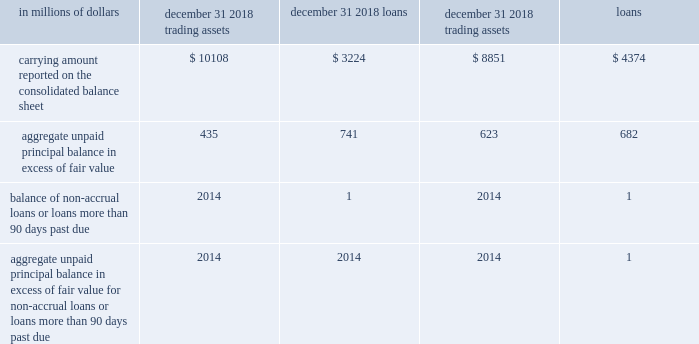Own debt valuation adjustments ( dva ) own debt valuation adjustments are recognized on citi 2019s liabilities for which the fair value option has been elected using citi 2019s credit spreads observed in the bond market .
Effective january 1 , 2016 , changes in fair value of fair value option liabilities related to changes in citigroup 2019s own credit spreads ( dva ) are reflected as a component of aoci .
See note 1 to the consolidated financial statements for additional information .
Among other variables , the fair value of liabilities for which the fair value option has been elected ( other than non-recourse and similar liabilities ) is impacted by the narrowing or widening of the company 2019s credit spreads .
The estimated changes in the fair value of these liabilities due to such changes in the company 2019s own credit spread ( or instrument-specific credit risk ) were a gain of $ 1415 million and a loss of $ 680 million for the years ended december 31 , 2018 and 2017 , respectively .
Changes in fair value resulting from changes in instrument-specific credit risk were estimated by incorporating the company 2019s current credit spreads observable in the bond market into the relevant valuation technique used to value each liability as described above .
The fair value option for financial assets and financial liabilities selected portfolios of securities purchased under agreements to resell , securities borrowed , securities sold under agreements to repurchase , securities loaned and certain non-collateralized short-term borrowings the company elected the fair value option for certain portfolios of fixed income securities purchased under agreements to resell and fixed income securities sold under agreements to repurchase , securities borrowed , securities loaned and certain non-collateralized short-term borrowings held primarily by broker-dealer entities in the united states , united kingdom and japan .
In each case , the election was made because the related interest rate risk is managed on a portfolio basis , primarily with offsetting derivative instruments that are accounted for at fair value through earnings .
Changes in fair value for transactions in these portfolios are recorded in principal transactions .
The related interest revenue and interest expense are measured based on the contractual rates specified in the transactions and are reported as interest revenue and interest expense in the consolidated statement of income .
Certain loans and other credit products citigroup has also elected the fair value option for certain other originated and purchased loans , including certain unfunded loan products , such as guarantees and letters of credit , executed by citigroup 2019s lending and trading businesses .
None of these credit products are highly leveraged financing commitments .
Significant groups of transactions include loans and unfunded loan products that are expected to be either sold or securitized in the near term , or transactions where the economic risks are hedged with derivative instruments , such as purchased credit default swaps or total return swaps where the company pays the total return on the underlying loans to a third party .
Citigroup has elected the fair value option to mitigate accounting mismatches in cases where hedge accounting is complex and to achieve operational simplifications .
Fair value was not elected for most lending transactions across the company .
The table provides information about certain credit products carried at fair value: .
In addition to the amounts reported above , $ 1137 million and $ 508 million of unfunded commitments related to certain credit products selected for fair value accounting were outstanding as of december 31 , 2018 and 2017 , respectively. .
What was the difference in millions of carrying amount reported on the consolidated balance sheet for trading assets between 2018 and the year prior? 
Computations: (10108 - 8851)
Answer: 1257.0. 